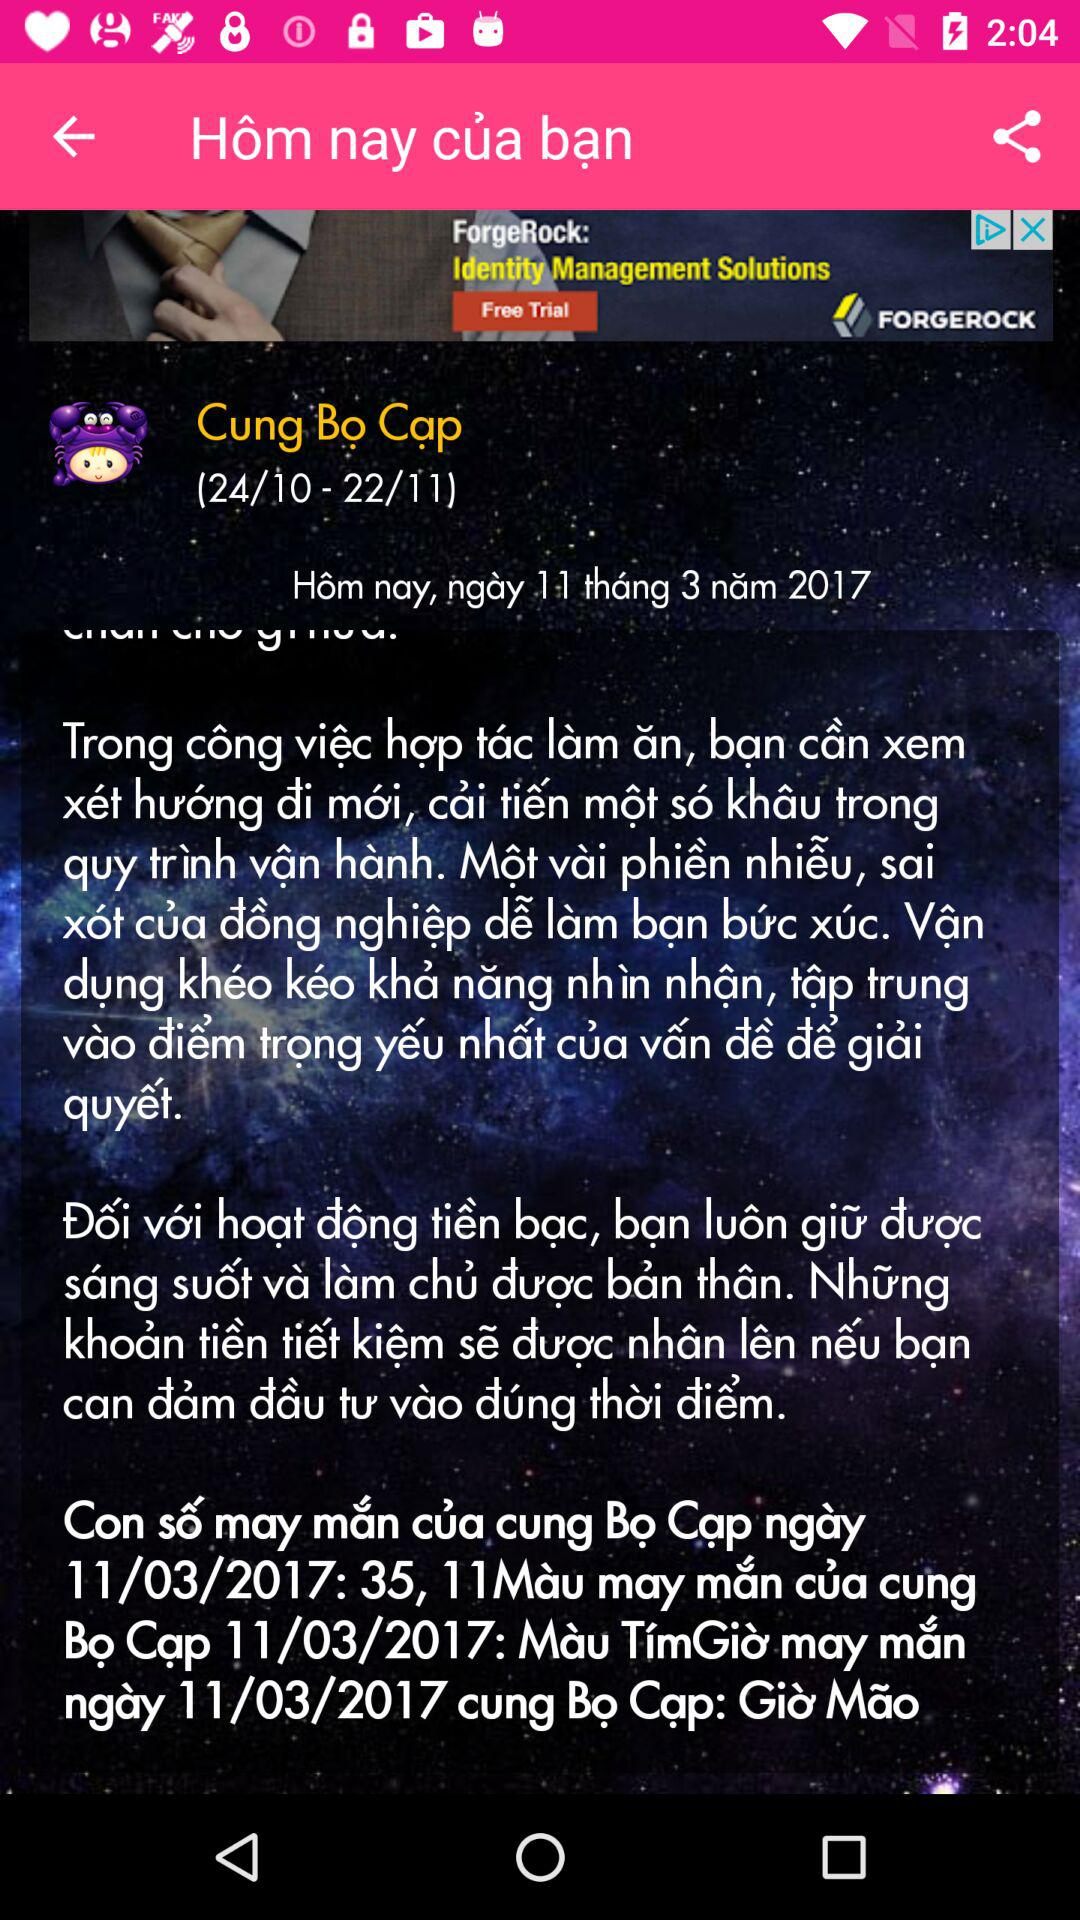What is the name of the crab?
Answer the question using a single word or phrase. Bo Cap 